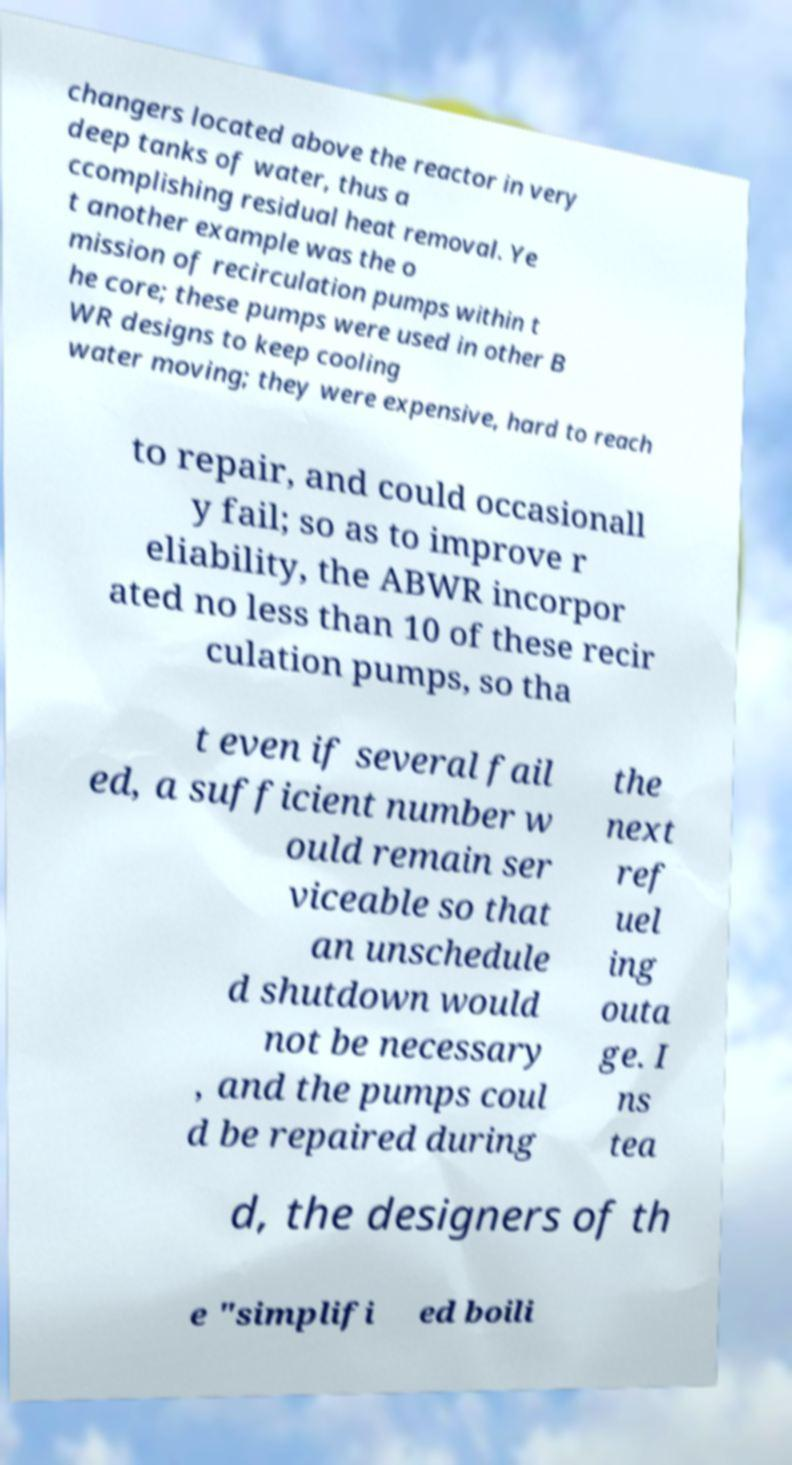Could you extract and type out the text from this image? changers located above the reactor in very deep tanks of water, thus a ccomplishing residual heat removal. Ye t another example was the o mission of recirculation pumps within t he core; these pumps were used in other B WR designs to keep cooling water moving; they were expensive, hard to reach to repair, and could occasionall y fail; so as to improve r eliability, the ABWR incorpor ated no less than 10 of these recir culation pumps, so tha t even if several fail ed, a sufficient number w ould remain ser viceable so that an unschedule d shutdown would not be necessary , and the pumps coul d be repaired during the next ref uel ing outa ge. I ns tea d, the designers of th e "simplifi ed boili 